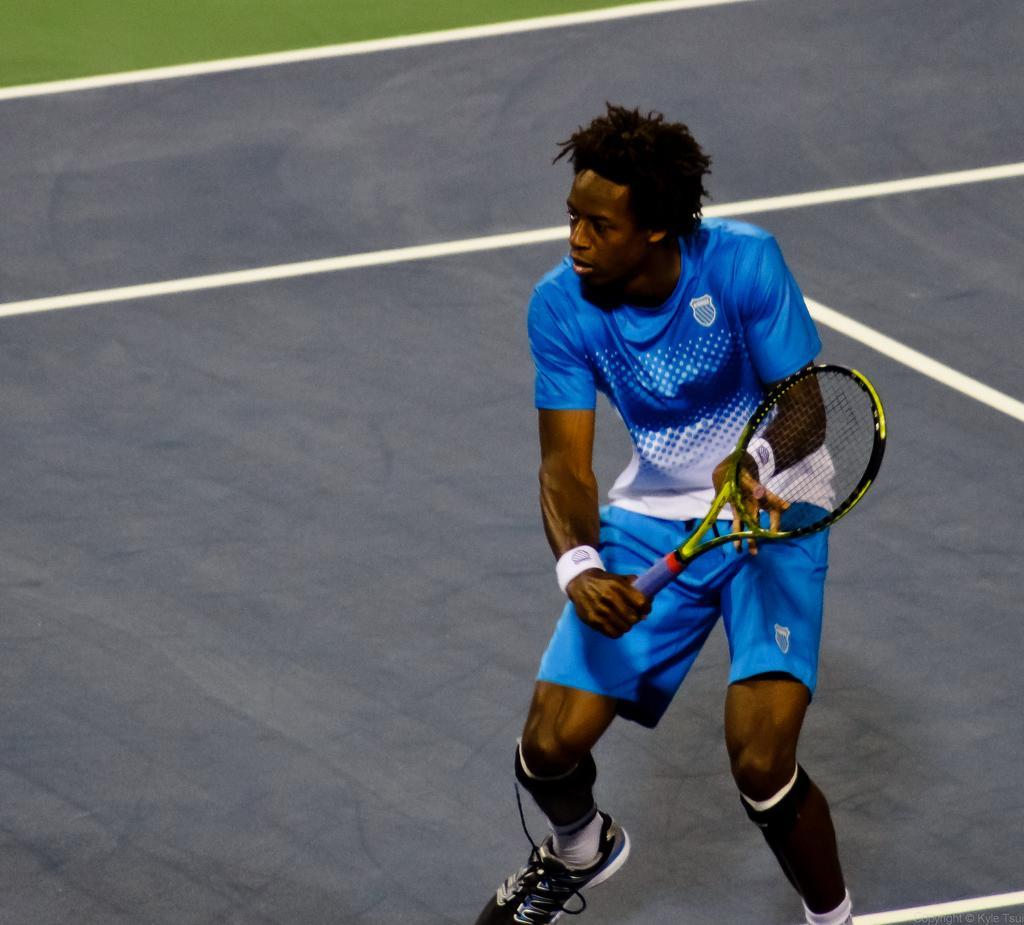How would you summarize this image in a sentence or two? In this picture we can see a man who is holding a racket with his hands. 